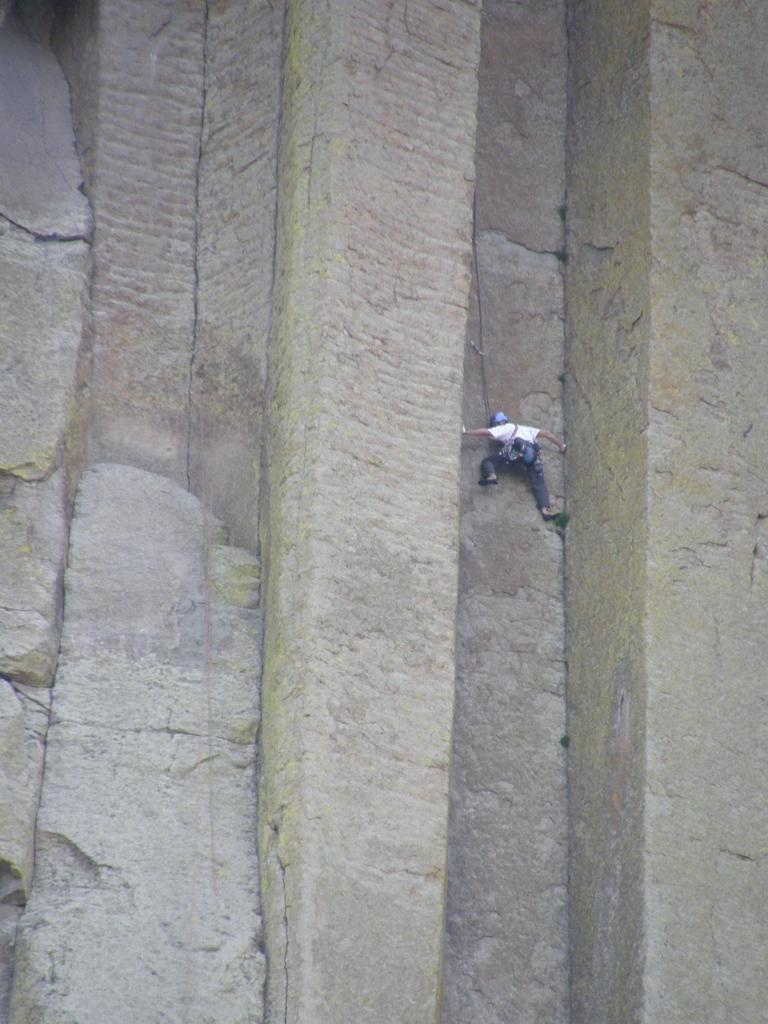What is present in the image? There is a wall in the image. What is the person in the image doing? A person is climbing the wall. What protective gear is the person wearing? The person is wearing a helmet. What else is the person carrying while climbing the wall? The person is wearing a bag. What type of sofa can be seen in the image? There is no sofa present in the image; it features a wall and a person climbing it. How deep is the hole the person is climbing out of in the image? There is no hole present in the image; it features a wall and a person climbing it. 